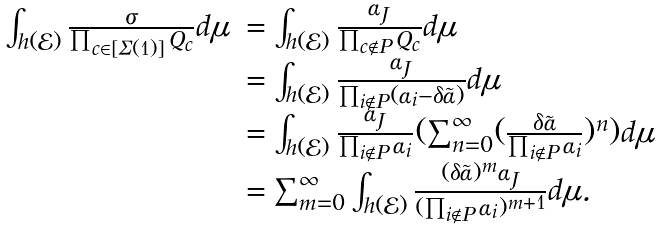Convert formula to latex. <formula><loc_0><loc_0><loc_500><loc_500>\begin{array} { l l } \int _ { h ( \mathcal { E } ) } \frac { \sigma } { \prod _ { c \in [ \Sigma ( 1 ) ] } Q _ { c } } d \mu & = \int _ { h ( \mathcal { E } ) } \frac { \alpha _ { J } } { \prod _ { c \not \in P } Q _ { c } } d \mu \\ & = \int _ { h ( \mathcal { E } ) } \frac { \alpha _ { J } } { \prod _ { i \not \in P } ( \alpha _ { i } - \delta \tilde { \alpha } ) } d \mu \\ & = \int _ { h ( \mathcal { E } ) } \frac { \alpha _ { J } } { \prod _ { i \not \in P } \alpha _ { i } } ( \sum _ { n = 0 } ^ { \infty } ( \frac { \delta \tilde { \alpha } } { \prod _ { i \not \in P } \alpha _ { i } } ) ^ { n } ) d \mu \\ & = \sum _ { m = 0 } ^ { \infty } \int _ { h ( \mathcal { E } ) } \frac { ( \delta \tilde { \alpha } ) ^ { m } \alpha _ { J } } { ( \prod _ { i \not \in P } \alpha _ { i } ) ^ { m + 1 } } d \mu . \end{array}</formula> 